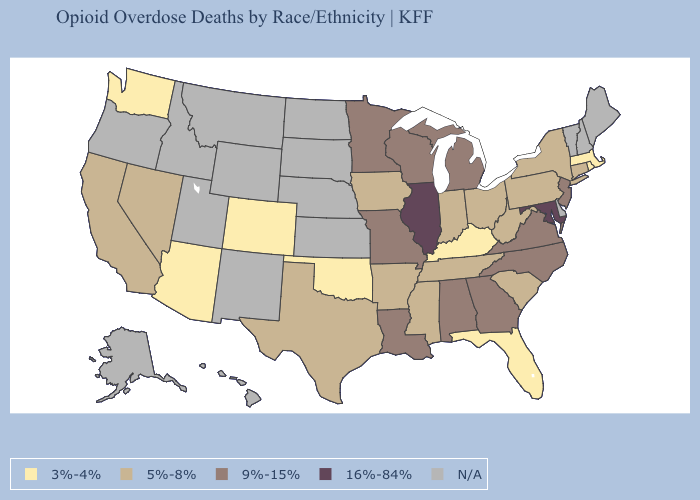What is the highest value in the South ?
Be succinct. 16%-84%. What is the lowest value in the South?
Keep it brief. 3%-4%. Which states have the lowest value in the MidWest?
Concise answer only. Indiana, Iowa, Ohio. What is the value of Illinois?
Quick response, please. 16%-84%. Name the states that have a value in the range 9%-15%?
Quick response, please. Alabama, Georgia, Louisiana, Michigan, Minnesota, Missouri, New Jersey, North Carolina, Virginia, Wisconsin. Name the states that have a value in the range N/A?
Quick response, please. Alaska, Delaware, Hawaii, Idaho, Kansas, Maine, Montana, Nebraska, New Hampshire, New Mexico, North Dakota, Oregon, South Dakota, Utah, Vermont, Wyoming. Name the states that have a value in the range 16%-84%?
Short answer required. Illinois, Maryland. What is the value of Missouri?
Write a very short answer. 9%-15%. Which states have the highest value in the USA?
Answer briefly. Illinois, Maryland. Name the states that have a value in the range 3%-4%?
Concise answer only. Arizona, Colorado, Florida, Kentucky, Massachusetts, Oklahoma, Rhode Island, Washington. Does Illinois have the highest value in the MidWest?
Quick response, please. Yes. What is the lowest value in the USA?
Give a very brief answer. 3%-4%. Does Connecticut have the highest value in the Northeast?
Short answer required. No. Name the states that have a value in the range 3%-4%?
Keep it brief. Arizona, Colorado, Florida, Kentucky, Massachusetts, Oklahoma, Rhode Island, Washington. Name the states that have a value in the range 3%-4%?
Keep it brief. Arizona, Colorado, Florida, Kentucky, Massachusetts, Oklahoma, Rhode Island, Washington. 